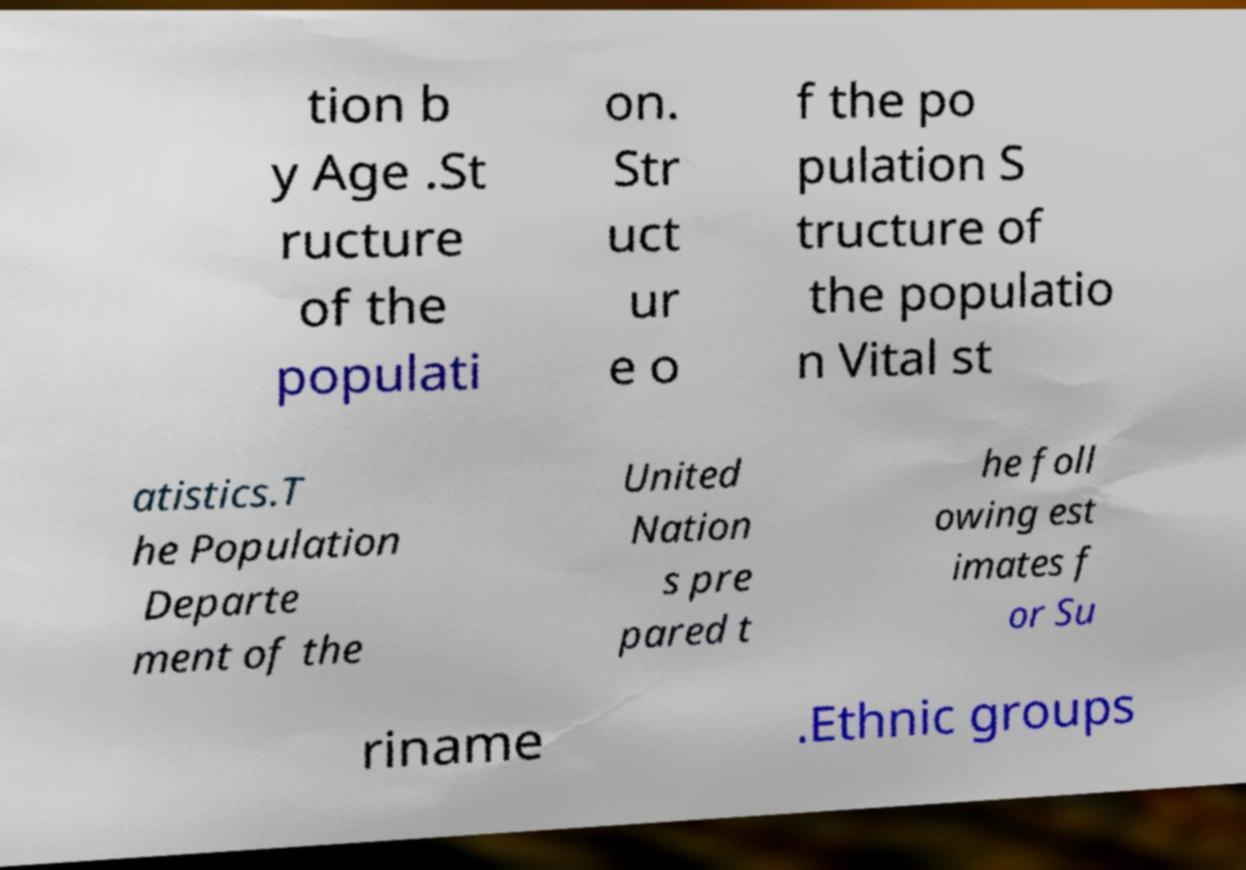Could you extract and type out the text from this image? tion b y Age .St ructure of the populati on. Str uct ur e o f the po pulation S tructure of the populatio n Vital st atistics.T he Population Departe ment of the United Nation s pre pared t he foll owing est imates f or Su riname .Ethnic groups 